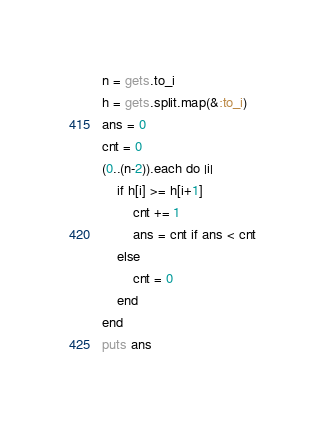Convert code to text. <code><loc_0><loc_0><loc_500><loc_500><_Ruby_>n = gets.to_i
h = gets.split.map(&:to_i)
ans = 0
cnt = 0
(0..(n-2)).each do |i|
    if h[i] >= h[i+1]
        cnt += 1
        ans = cnt if ans < cnt
    else
        cnt = 0
    end
end
puts ans</code> 